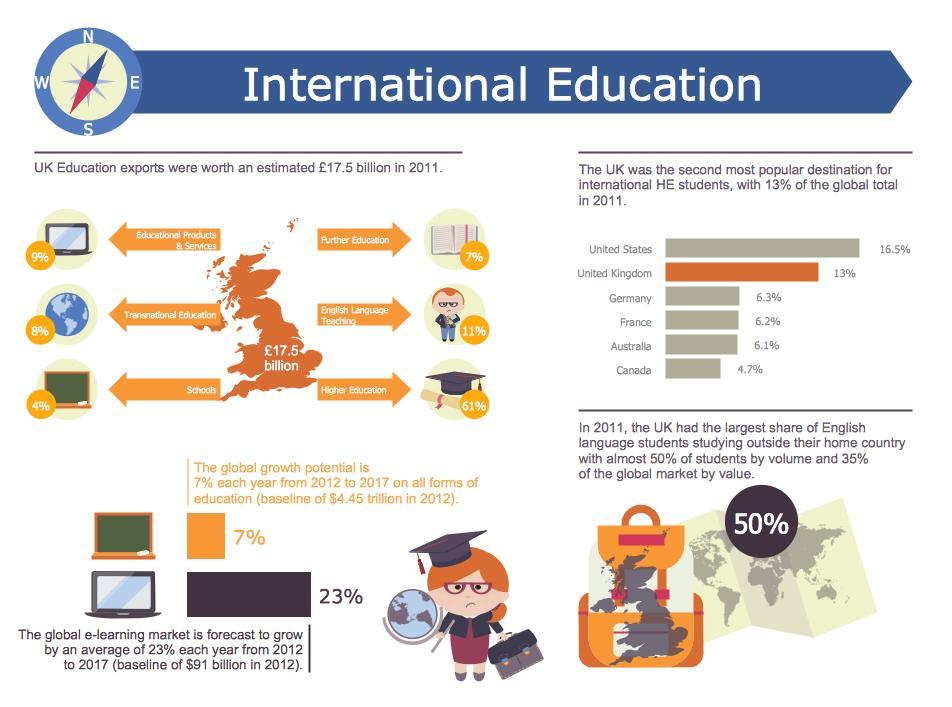What will be the growth in e-learning market in billions in 2013, if it grows at 23%? ?
Answer the question with a short phrase. $111 billion What will be the growth in education in trillions in 2013, if the global growth potential is 7% ? $4.76 trillion What is total percentage of popular destinations for education? 52.8% Which was the fourth popular destination for education for international students? France 